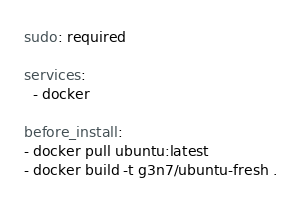Convert code to text. <code><loc_0><loc_0><loc_500><loc_500><_YAML_>sudo: required

services:
  - docker

before_install:
- docker pull ubuntu:latest
- docker build -t g3n7/ubuntu-fresh .</code> 